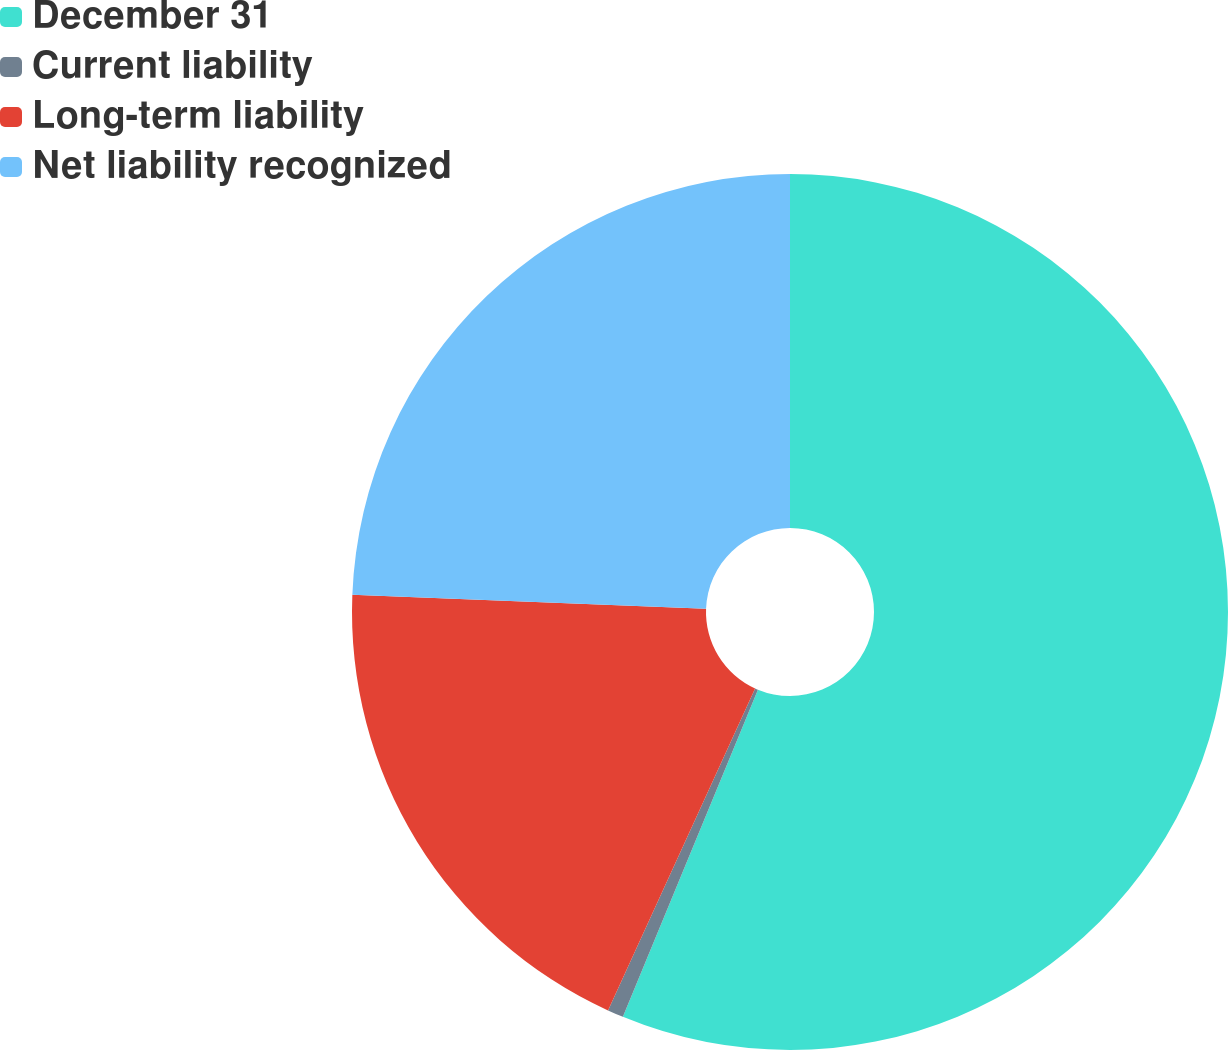Convert chart to OTSL. <chart><loc_0><loc_0><loc_500><loc_500><pie_chart><fcel>December 31<fcel>Current liability<fcel>Long-term liability<fcel>Net liability recognized<nl><fcel>56.23%<fcel>0.59%<fcel>18.81%<fcel>24.37%<nl></chart> 